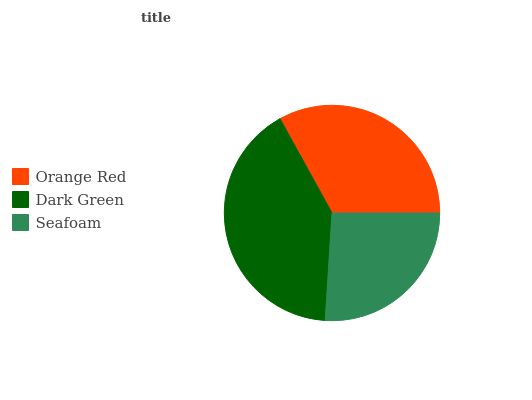Is Seafoam the minimum?
Answer yes or no. Yes. Is Dark Green the maximum?
Answer yes or no. Yes. Is Dark Green the minimum?
Answer yes or no. No. Is Seafoam the maximum?
Answer yes or no. No. Is Dark Green greater than Seafoam?
Answer yes or no. Yes. Is Seafoam less than Dark Green?
Answer yes or no. Yes. Is Seafoam greater than Dark Green?
Answer yes or no. No. Is Dark Green less than Seafoam?
Answer yes or no. No. Is Orange Red the high median?
Answer yes or no. Yes. Is Orange Red the low median?
Answer yes or no. Yes. Is Seafoam the high median?
Answer yes or no. No. Is Dark Green the low median?
Answer yes or no. No. 